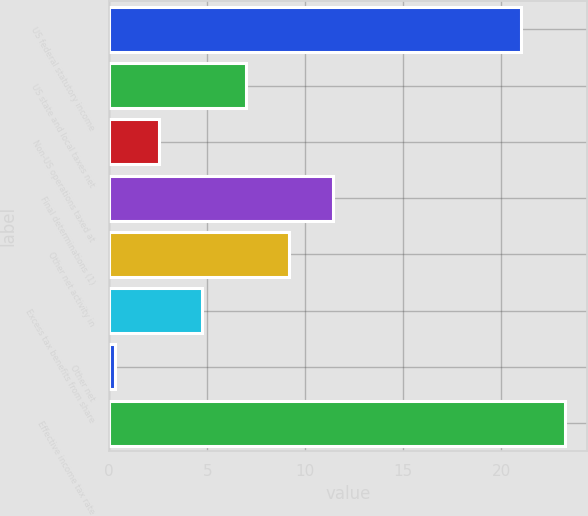Convert chart. <chart><loc_0><loc_0><loc_500><loc_500><bar_chart><fcel>US federal statutory income<fcel>US state and local taxes net<fcel>Non-US operations taxed at<fcel>Final determinations (1)<fcel>Other net activity in<fcel>Excess tax benefits from share<fcel>Other net<fcel>Effective income tax rate<nl><fcel>21<fcel>6.96<fcel>2.52<fcel>11.4<fcel>9.18<fcel>4.74<fcel>0.3<fcel>23.22<nl></chart> 